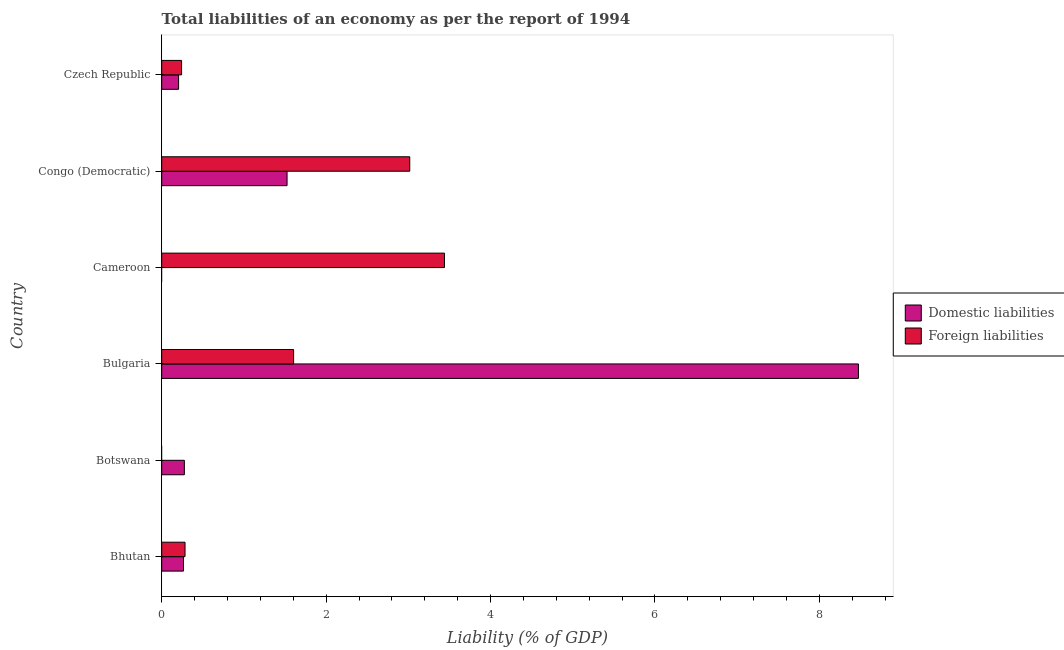How many different coloured bars are there?
Offer a terse response. 2. How many bars are there on the 2nd tick from the top?
Offer a very short reply. 2. What is the label of the 2nd group of bars from the top?
Keep it short and to the point. Congo (Democratic). In how many cases, is the number of bars for a given country not equal to the number of legend labels?
Your response must be concise. 2. What is the incurrence of domestic liabilities in Congo (Democratic)?
Your answer should be compact. 1.52. Across all countries, what is the maximum incurrence of foreign liabilities?
Provide a succinct answer. 3.44. In which country was the incurrence of foreign liabilities maximum?
Give a very brief answer. Cameroon. What is the total incurrence of domestic liabilities in the graph?
Your response must be concise. 10.75. What is the difference between the incurrence of foreign liabilities in Cameroon and that in Czech Republic?
Keep it short and to the point. 3.2. What is the difference between the incurrence of domestic liabilities in Botswana and the incurrence of foreign liabilities in Czech Republic?
Ensure brevity in your answer.  0.03. What is the average incurrence of foreign liabilities per country?
Offer a terse response. 1.43. What is the difference between the incurrence of foreign liabilities and incurrence of domestic liabilities in Bhutan?
Your response must be concise. 0.02. What is the ratio of the incurrence of domestic liabilities in Botswana to that in Czech Republic?
Make the answer very short. 1.34. What is the difference between the highest and the second highest incurrence of foreign liabilities?
Make the answer very short. 0.42. What is the difference between the highest and the lowest incurrence of domestic liabilities?
Your answer should be very brief. 8.48. In how many countries, is the incurrence of foreign liabilities greater than the average incurrence of foreign liabilities taken over all countries?
Your answer should be very brief. 3. Is the sum of the incurrence of foreign liabilities in Bulgaria and Congo (Democratic) greater than the maximum incurrence of domestic liabilities across all countries?
Give a very brief answer. No. How many countries are there in the graph?
Provide a short and direct response. 6. What is the difference between two consecutive major ticks on the X-axis?
Offer a very short reply. 2. Does the graph contain any zero values?
Offer a terse response. Yes. Does the graph contain grids?
Offer a terse response. No. Where does the legend appear in the graph?
Make the answer very short. Center right. How are the legend labels stacked?
Your answer should be compact. Vertical. What is the title of the graph?
Your answer should be very brief. Total liabilities of an economy as per the report of 1994. Does "Primary school" appear as one of the legend labels in the graph?
Provide a short and direct response. No. What is the label or title of the X-axis?
Make the answer very short. Liability (% of GDP). What is the label or title of the Y-axis?
Offer a very short reply. Country. What is the Liability (% of GDP) in Domestic liabilities in Bhutan?
Your answer should be very brief. 0.26. What is the Liability (% of GDP) in Foreign liabilities in Bhutan?
Provide a succinct answer. 0.28. What is the Liability (% of GDP) in Domestic liabilities in Botswana?
Offer a terse response. 0.28. What is the Liability (% of GDP) in Domestic liabilities in Bulgaria?
Offer a very short reply. 8.48. What is the Liability (% of GDP) of Foreign liabilities in Bulgaria?
Your response must be concise. 1.6. What is the Liability (% of GDP) of Domestic liabilities in Cameroon?
Offer a very short reply. 0. What is the Liability (% of GDP) in Foreign liabilities in Cameroon?
Ensure brevity in your answer.  3.44. What is the Liability (% of GDP) in Domestic liabilities in Congo (Democratic)?
Offer a terse response. 1.52. What is the Liability (% of GDP) of Foreign liabilities in Congo (Democratic)?
Offer a terse response. 3.02. What is the Liability (% of GDP) of Domestic liabilities in Czech Republic?
Your answer should be very brief. 0.21. What is the Liability (% of GDP) of Foreign liabilities in Czech Republic?
Offer a terse response. 0.24. Across all countries, what is the maximum Liability (% of GDP) in Domestic liabilities?
Keep it short and to the point. 8.48. Across all countries, what is the maximum Liability (% of GDP) of Foreign liabilities?
Give a very brief answer. 3.44. Across all countries, what is the minimum Liability (% of GDP) in Domestic liabilities?
Offer a very short reply. 0. Across all countries, what is the minimum Liability (% of GDP) in Foreign liabilities?
Your response must be concise. 0. What is the total Liability (% of GDP) in Domestic liabilities in the graph?
Make the answer very short. 10.75. What is the total Liability (% of GDP) of Foreign liabilities in the graph?
Keep it short and to the point. 8.59. What is the difference between the Liability (% of GDP) in Domestic liabilities in Bhutan and that in Botswana?
Offer a terse response. -0.01. What is the difference between the Liability (% of GDP) in Domestic liabilities in Bhutan and that in Bulgaria?
Give a very brief answer. -8.21. What is the difference between the Liability (% of GDP) of Foreign liabilities in Bhutan and that in Bulgaria?
Your answer should be compact. -1.32. What is the difference between the Liability (% of GDP) in Foreign liabilities in Bhutan and that in Cameroon?
Provide a succinct answer. -3.16. What is the difference between the Liability (% of GDP) in Domestic liabilities in Bhutan and that in Congo (Democratic)?
Your answer should be very brief. -1.26. What is the difference between the Liability (% of GDP) of Foreign liabilities in Bhutan and that in Congo (Democratic)?
Your response must be concise. -2.73. What is the difference between the Liability (% of GDP) of Domestic liabilities in Bhutan and that in Czech Republic?
Give a very brief answer. 0.06. What is the difference between the Liability (% of GDP) in Foreign liabilities in Bhutan and that in Czech Republic?
Provide a short and direct response. 0.04. What is the difference between the Liability (% of GDP) in Domestic liabilities in Botswana and that in Bulgaria?
Your response must be concise. -8.2. What is the difference between the Liability (% of GDP) of Domestic liabilities in Botswana and that in Congo (Democratic)?
Your response must be concise. -1.25. What is the difference between the Liability (% of GDP) of Domestic liabilities in Botswana and that in Czech Republic?
Your response must be concise. 0.07. What is the difference between the Liability (% of GDP) of Foreign liabilities in Bulgaria and that in Cameroon?
Your answer should be compact. -1.84. What is the difference between the Liability (% of GDP) in Domestic liabilities in Bulgaria and that in Congo (Democratic)?
Provide a succinct answer. 6.95. What is the difference between the Liability (% of GDP) in Foreign liabilities in Bulgaria and that in Congo (Democratic)?
Your answer should be compact. -1.41. What is the difference between the Liability (% of GDP) of Domestic liabilities in Bulgaria and that in Czech Republic?
Your answer should be very brief. 8.27. What is the difference between the Liability (% of GDP) of Foreign liabilities in Bulgaria and that in Czech Republic?
Give a very brief answer. 1.36. What is the difference between the Liability (% of GDP) in Foreign liabilities in Cameroon and that in Congo (Democratic)?
Provide a succinct answer. 0.42. What is the difference between the Liability (% of GDP) of Foreign liabilities in Cameroon and that in Czech Republic?
Provide a succinct answer. 3.2. What is the difference between the Liability (% of GDP) in Domestic liabilities in Congo (Democratic) and that in Czech Republic?
Your answer should be compact. 1.32. What is the difference between the Liability (% of GDP) of Foreign liabilities in Congo (Democratic) and that in Czech Republic?
Your answer should be very brief. 2.78. What is the difference between the Liability (% of GDP) in Domestic liabilities in Bhutan and the Liability (% of GDP) in Foreign liabilities in Bulgaria?
Your response must be concise. -1.34. What is the difference between the Liability (% of GDP) of Domestic liabilities in Bhutan and the Liability (% of GDP) of Foreign liabilities in Cameroon?
Keep it short and to the point. -3.18. What is the difference between the Liability (% of GDP) in Domestic liabilities in Bhutan and the Liability (% of GDP) in Foreign liabilities in Congo (Democratic)?
Give a very brief answer. -2.75. What is the difference between the Liability (% of GDP) of Domestic liabilities in Bhutan and the Liability (% of GDP) of Foreign liabilities in Czech Republic?
Offer a very short reply. 0.02. What is the difference between the Liability (% of GDP) in Domestic liabilities in Botswana and the Liability (% of GDP) in Foreign liabilities in Bulgaria?
Give a very brief answer. -1.33. What is the difference between the Liability (% of GDP) of Domestic liabilities in Botswana and the Liability (% of GDP) of Foreign liabilities in Cameroon?
Ensure brevity in your answer.  -3.16. What is the difference between the Liability (% of GDP) of Domestic liabilities in Botswana and the Liability (% of GDP) of Foreign liabilities in Congo (Democratic)?
Ensure brevity in your answer.  -2.74. What is the difference between the Liability (% of GDP) in Domestic liabilities in Botswana and the Liability (% of GDP) in Foreign liabilities in Czech Republic?
Offer a terse response. 0.03. What is the difference between the Liability (% of GDP) of Domestic liabilities in Bulgaria and the Liability (% of GDP) of Foreign liabilities in Cameroon?
Offer a terse response. 5.04. What is the difference between the Liability (% of GDP) in Domestic liabilities in Bulgaria and the Liability (% of GDP) in Foreign liabilities in Congo (Democratic)?
Your answer should be compact. 5.46. What is the difference between the Liability (% of GDP) in Domestic liabilities in Bulgaria and the Liability (% of GDP) in Foreign liabilities in Czech Republic?
Make the answer very short. 8.23. What is the difference between the Liability (% of GDP) of Domestic liabilities in Congo (Democratic) and the Liability (% of GDP) of Foreign liabilities in Czech Republic?
Keep it short and to the point. 1.28. What is the average Liability (% of GDP) of Domestic liabilities per country?
Your answer should be compact. 1.79. What is the average Liability (% of GDP) in Foreign liabilities per country?
Offer a terse response. 1.43. What is the difference between the Liability (% of GDP) in Domestic liabilities and Liability (% of GDP) in Foreign liabilities in Bhutan?
Make the answer very short. -0.02. What is the difference between the Liability (% of GDP) of Domestic liabilities and Liability (% of GDP) of Foreign liabilities in Bulgaria?
Ensure brevity in your answer.  6.87. What is the difference between the Liability (% of GDP) in Domestic liabilities and Liability (% of GDP) in Foreign liabilities in Congo (Democratic)?
Keep it short and to the point. -1.49. What is the difference between the Liability (% of GDP) of Domestic liabilities and Liability (% of GDP) of Foreign liabilities in Czech Republic?
Keep it short and to the point. -0.04. What is the ratio of the Liability (% of GDP) of Domestic liabilities in Bhutan to that in Botswana?
Ensure brevity in your answer.  0.96. What is the ratio of the Liability (% of GDP) of Domestic liabilities in Bhutan to that in Bulgaria?
Give a very brief answer. 0.03. What is the ratio of the Liability (% of GDP) in Foreign liabilities in Bhutan to that in Bulgaria?
Your answer should be very brief. 0.18. What is the ratio of the Liability (% of GDP) of Foreign liabilities in Bhutan to that in Cameroon?
Your answer should be very brief. 0.08. What is the ratio of the Liability (% of GDP) in Domestic liabilities in Bhutan to that in Congo (Democratic)?
Ensure brevity in your answer.  0.17. What is the ratio of the Liability (% of GDP) of Foreign liabilities in Bhutan to that in Congo (Democratic)?
Your response must be concise. 0.09. What is the ratio of the Liability (% of GDP) of Domestic liabilities in Bhutan to that in Czech Republic?
Your response must be concise. 1.29. What is the ratio of the Liability (% of GDP) in Foreign liabilities in Bhutan to that in Czech Republic?
Provide a succinct answer. 1.17. What is the ratio of the Liability (% of GDP) of Domestic liabilities in Botswana to that in Bulgaria?
Give a very brief answer. 0.03. What is the ratio of the Liability (% of GDP) of Domestic liabilities in Botswana to that in Congo (Democratic)?
Your answer should be very brief. 0.18. What is the ratio of the Liability (% of GDP) in Domestic liabilities in Botswana to that in Czech Republic?
Offer a terse response. 1.34. What is the ratio of the Liability (% of GDP) in Foreign liabilities in Bulgaria to that in Cameroon?
Ensure brevity in your answer.  0.47. What is the ratio of the Liability (% of GDP) in Domestic liabilities in Bulgaria to that in Congo (Democratic)?
Ensure brevity in your answer.  5.56. What is the ratio of the Liability (% of GDP) of Foreign liabilities in Bulgaria to that in Congo (Democratic)?
Provide a short and direct response. 0.53. What is the ratio of the Liability (% of GDP) of Domestic liabilities in Bulgaria to that in Czech Republic?
Ensure brevity in your answer.  41.27. What is the ratio of the Liability (% of GDP) of Foreign liabilities in Bulgaria to that in Czech Republic?
Provide a succinct answer. 6.64. What is the ratio of the Liability (% of GDP) in Foreign liabilities in Cameroon to that in Congo (Democratic)?
Provide a succinct answer. 1.14. What is the ratio of the Liability (% of GDP) in Foreign liabilities in Cameroon to that in Czech Republic?
Your answer should be compact. 14.23. What is the ratio of the Liability (% of GDP) in Domestic liabilities in Congo (Democratic) to that in Czech Republic?
Your answer should be very brief. 7.42. What is the ratio of the Liability (% of GDP) in Foreign liabilities in Congo (Democratic) to that in Czech Republic?
Your answer should be very brief. 12.48. What is the difference between the highest and the second highest Liability (% of GDP) of Domestic liabilities?
Your response must be concise. 6.95. What is the difference between the highest and the second highest Liability (% of GDP) of Foreign liabilities?
Provide a short and direct response. 0.42. What is the difference between the highest and the lowest Liability (% of GDP) of Domestic liabilities?
Make the answer very short. 8.48. What is the difference between the highest and the lowest Liability (% of GDP) in Foreign liabilities?
Offer a very short reply. 3.44. 